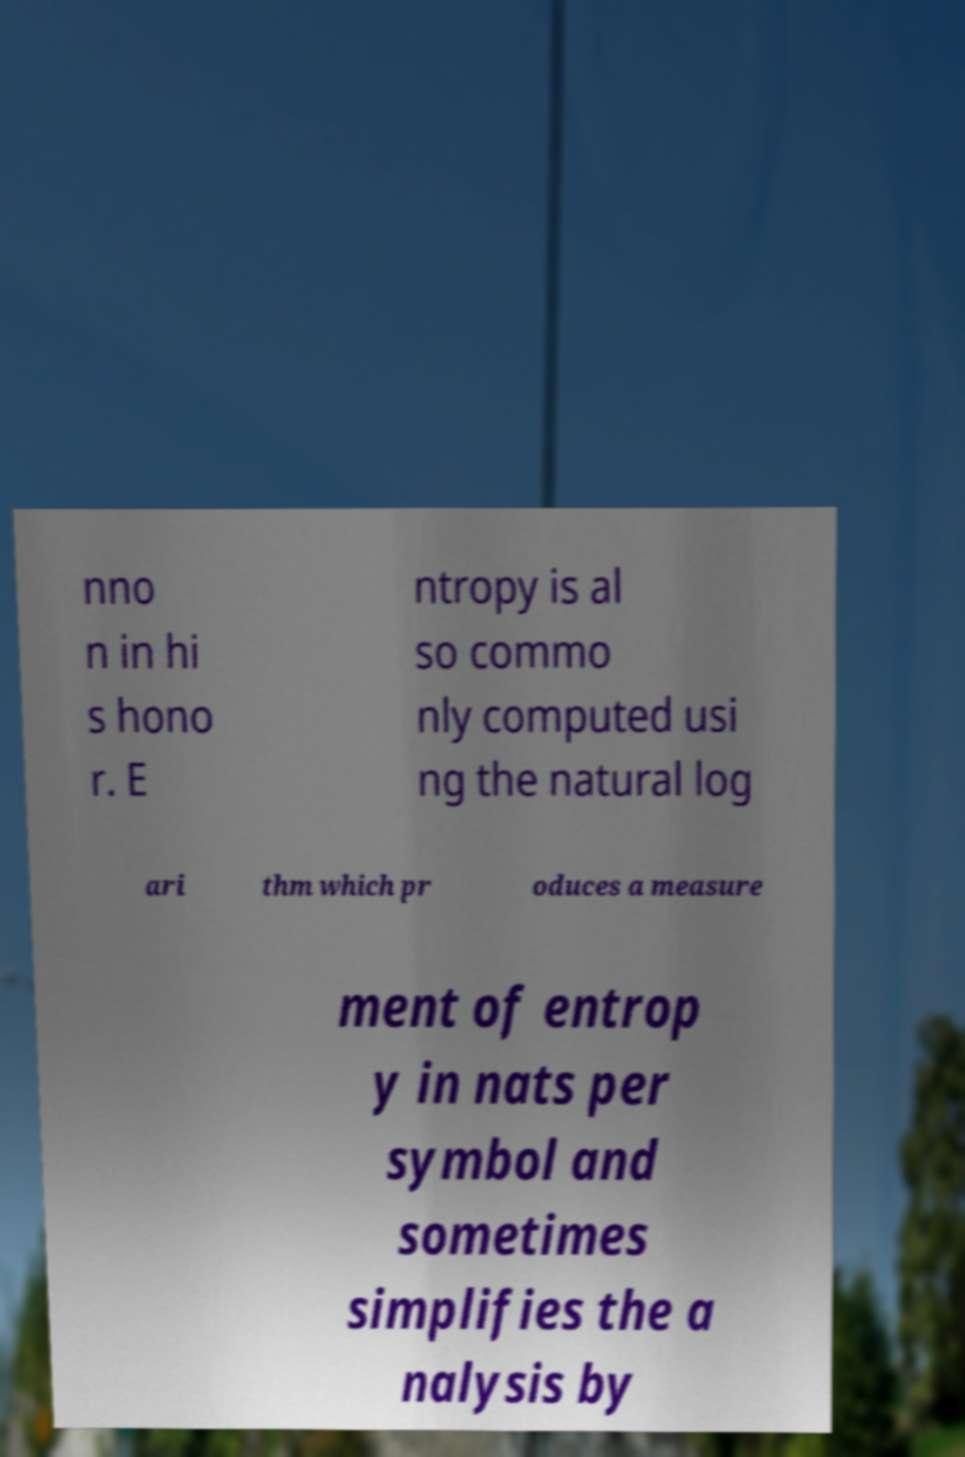Please identify and transcribe the text found in this image. nno n in hi s hono r. E ntropy is al so commo nly computed usi ng the natural log ari thm which pr oduces a measure ment of entrop y in nats per symbol and sometimes simplifies the a nalysis by 